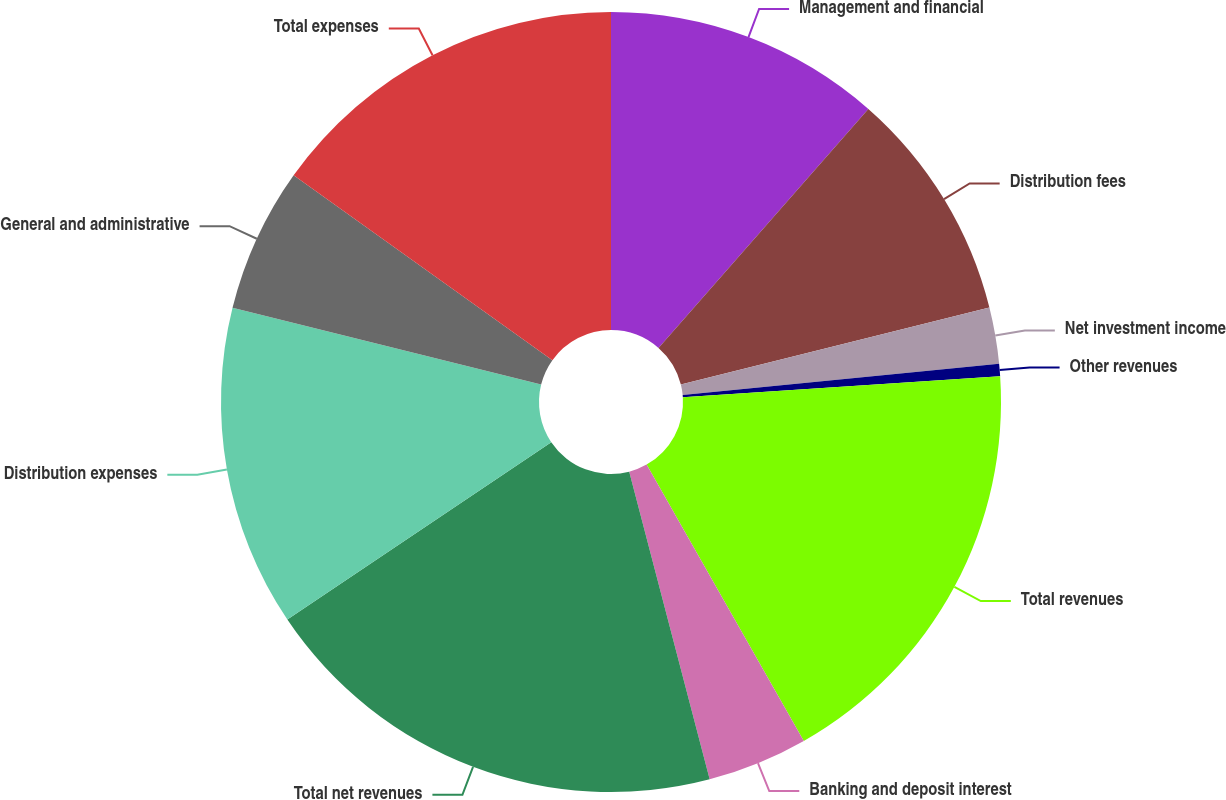<chart> <loc_0><loc_0><loc_500><loc_500><pie_chart><fcel>Management and financial<fcel>Distribution fees<fcel>Net investment income<fcel>Other revenues<fcel>Total revenues<fcel>Banking and deposit interest<fcel>Total net revenues<fcel>Distribution expenses<fcel>General and administrative<fcel>Total expenses<nl><fcel>11.47%<fcel>9.64%<fcel>2.33%<fcel>0.51%<fcel>17.82%<fcel>4.16%<fcel>19.65%<fcel>13.3%<fcel>5.99%<fcel>15.13%<nl></chart> 